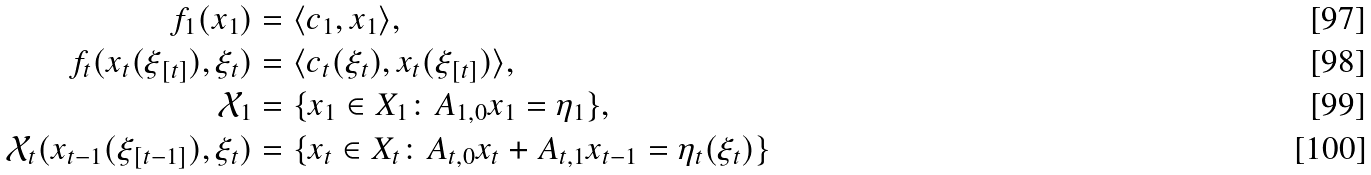Convert formula to latex. <formula><loc_0><loc_0><loc_500><loc_500>f _ { 1 } ( x _ { 1 } ) & = \langle c _ { 1 } , x _ { 1 } \rangle , \\ f _ { t } ( x _ { t } ( \xi _ { [ t ] } ) , \xi _ { t } ) & = \langle c _ { t } ( \xi _ { t } ) , x _ { t } ( \xi _ { [ t ] } ) \rangle , \\ \mathcal { X } _ { 1 } & = \{ x _ { 1 } \in X _ { 1 } \colon A _ { 1 , 0 } x _ { 1 } = \eta _ { 1 } \} , \\ \mathcal { X } _ { t } ( x _ { t - 1 } ( \xi _ { [ t - 1 ] } ) , \xi _ { t } ) & = \{ x _ { t } \in X _ { t } \colon A _ { t , 0 } x _ { t } + A _ { t , 1 } x _ { t - 1 } = \eta _ { t } ( \xi _ { t } ) \}</formula> 